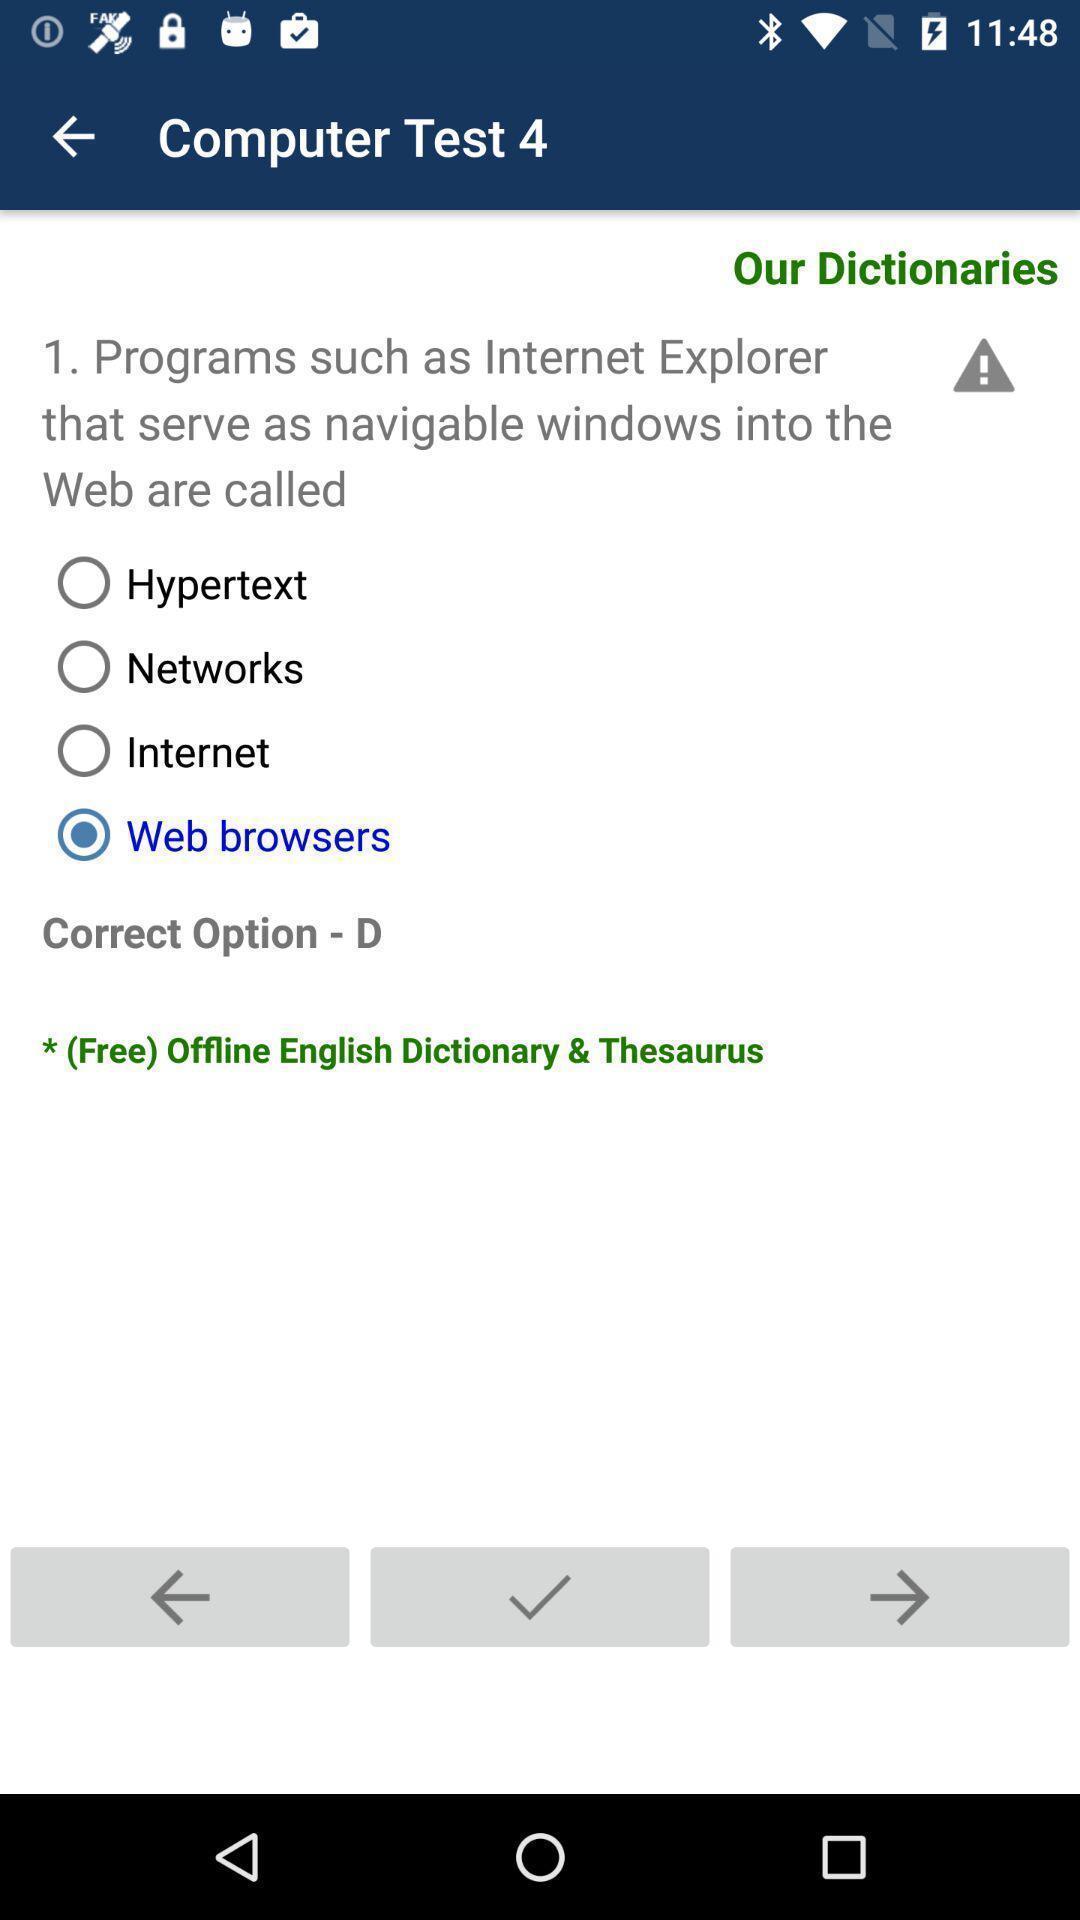Provide a description of this screenshot. Page showing the mcq question in learning app. 